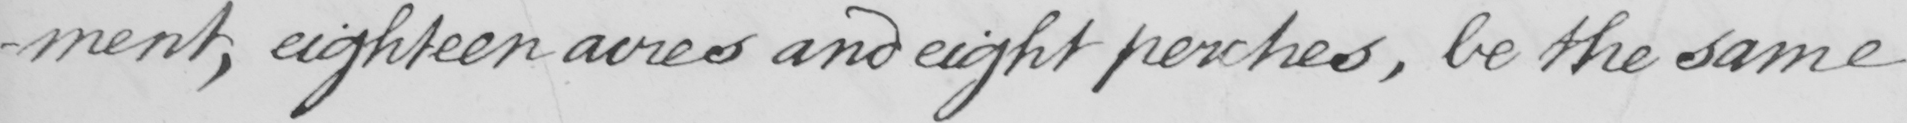Please transcribe the handwritten text in this image. -ment , eighteen acres and eight perches , be the same 